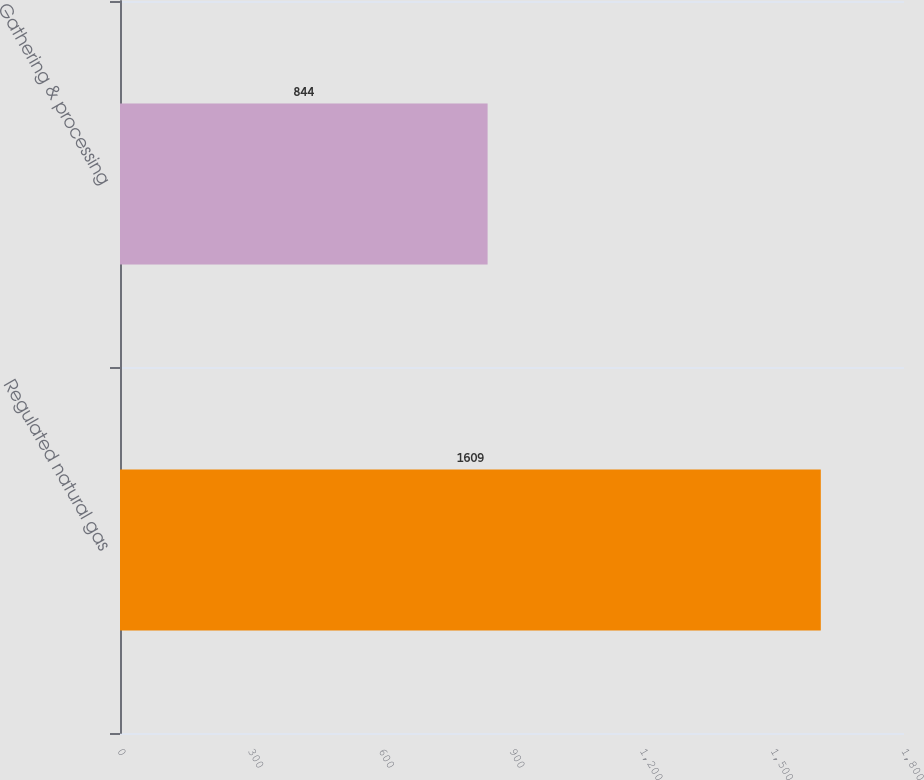Convert chart. <chart><loc_0><loc_0><loc_500><loc_500><bar_chart><fcel>Regulated natural gas<fcel>Gathering & processing<nl><fcel>1609<fcel>844<nl></chart> 